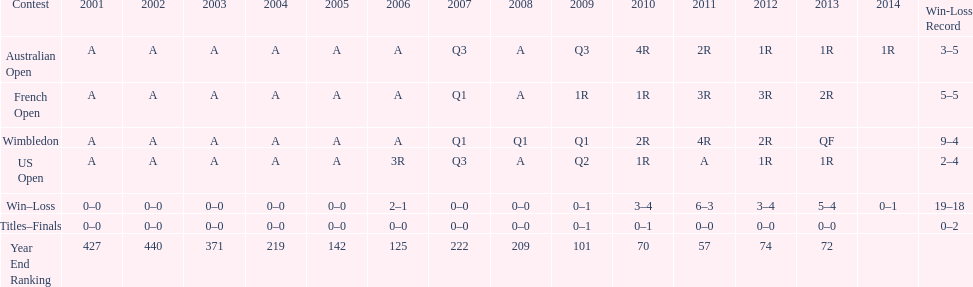Which years was a ranking below 200 achieved? 2005, 2006, 2009, 2010, 2011, 2012, 2013. 